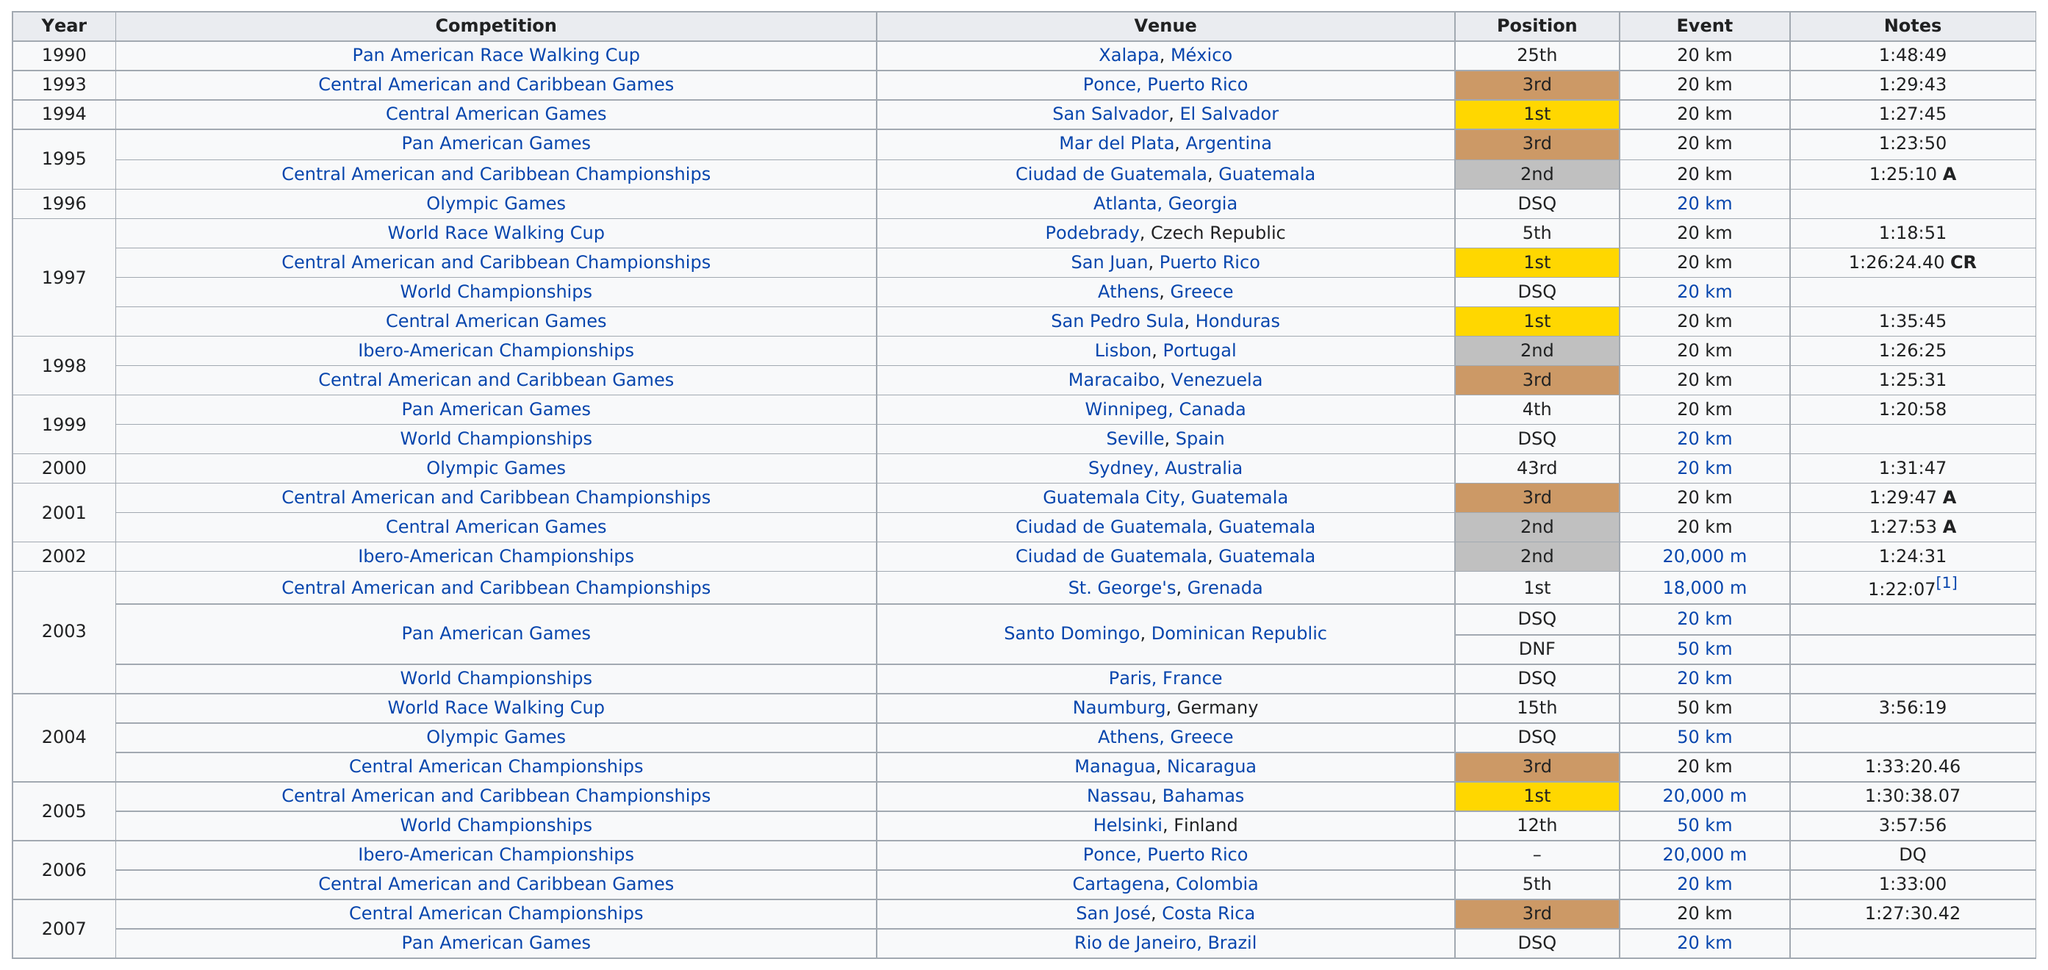Give some essential details in this illustration. The year with the most disqualifications was 2003. The only event that Maritnez ran before he ran the 20,000m in the 2002 Ibero-American Championships was a 20km race. In 1997, he won first place two times. The individual's number of disqualifications is 7. According to the information provided, Martinez ran the 20 km at the Central American Games in 1994 in a time of 1 hour and 27 minutes and 45 seconds. 